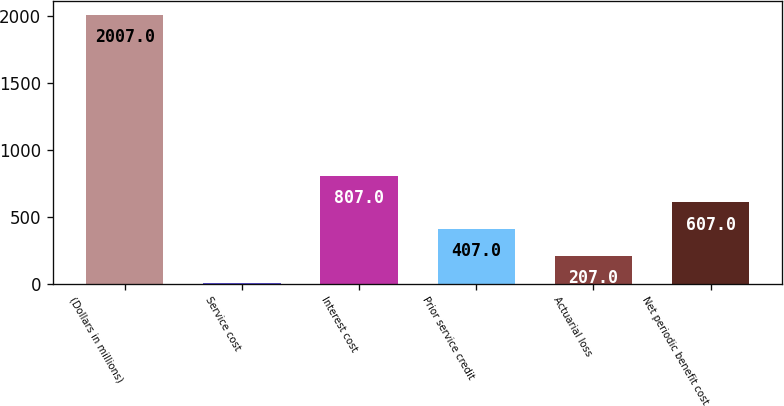<chart> <loc_0><loc_0><loc_500><loc_500><bar_chart><fcel>(Dollars in millions)<fcel>Service cost<fcel>Interest cost<fcel>Prior service credit<fcel>Actuarial loss<fcel>Net periodic benefit cost<nl><fcel>2007<fcel>7<fcel>807<fcel>407<fcel>207<fcel>607<nl></chart> 